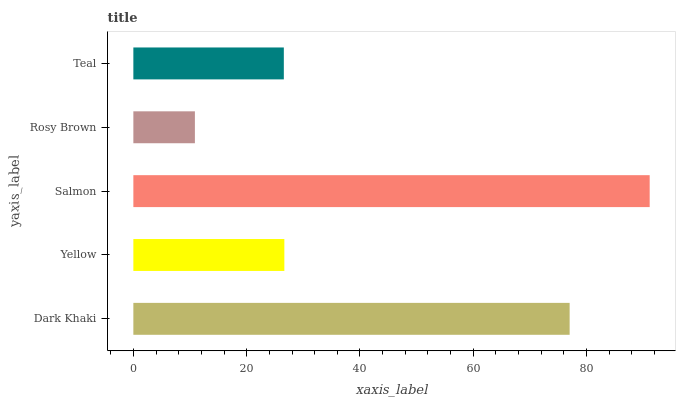Is Rosy Brown the minimum?
Answer yes or no. Yes. Is Salmon the maximum?
Answer yes or no. Yes. Is Yellow the minimum?
Answer yes or no. No. Is Yellow the maximum?
Answer yes or no. No. Is Dark Khaki greater than Yellow?
Answer yes or no. Yes. Is Yellow less than Dark Khaki?
Answer yes or no. Yes. Is Yellow greater than Dark Khaki?
Answer yes or no. No. Is Dark Khaki less than Yellow?
Answer yes or no. No. Is Yellow the high median?
Answer yes or no. Yes. Is Yellow the low median?
Answer yes or no. Yes. Is Teal the high median?
Answer yes or no. No. Is Teal the low median?
Answer yes or no. No. 